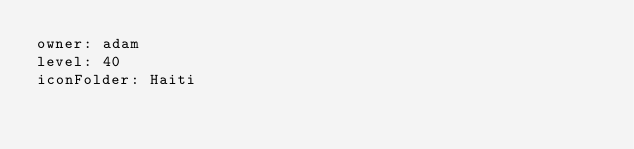Convert code to text. <code><loc_0><loc_0><loc_500><loc_500><_YAML_>owner: adam
level: 40
iconFolder: Haiti</code> 